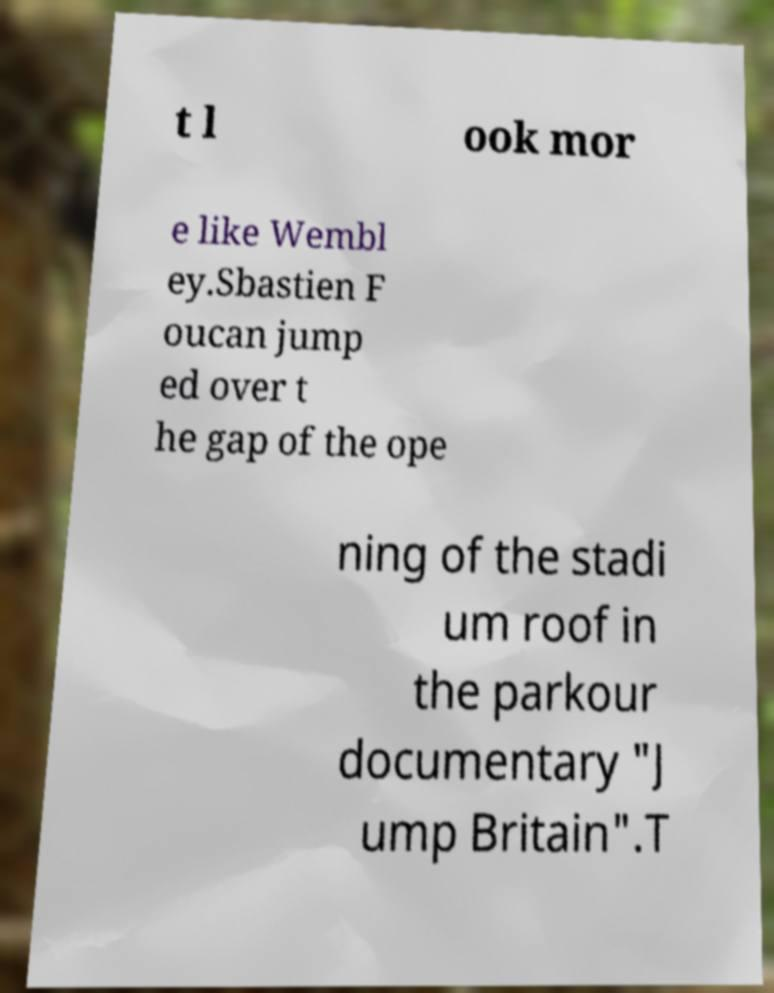Can you read and provide the text displayed in the image?This photo seems to have some interesting text. Can you extract and type it out for me? t l ook mor e like Wembl ey.Sbastien F oucan jump ed over t he gap of the ope ning of the stadi um roof in the parkour documentary "J ump Britain".T 